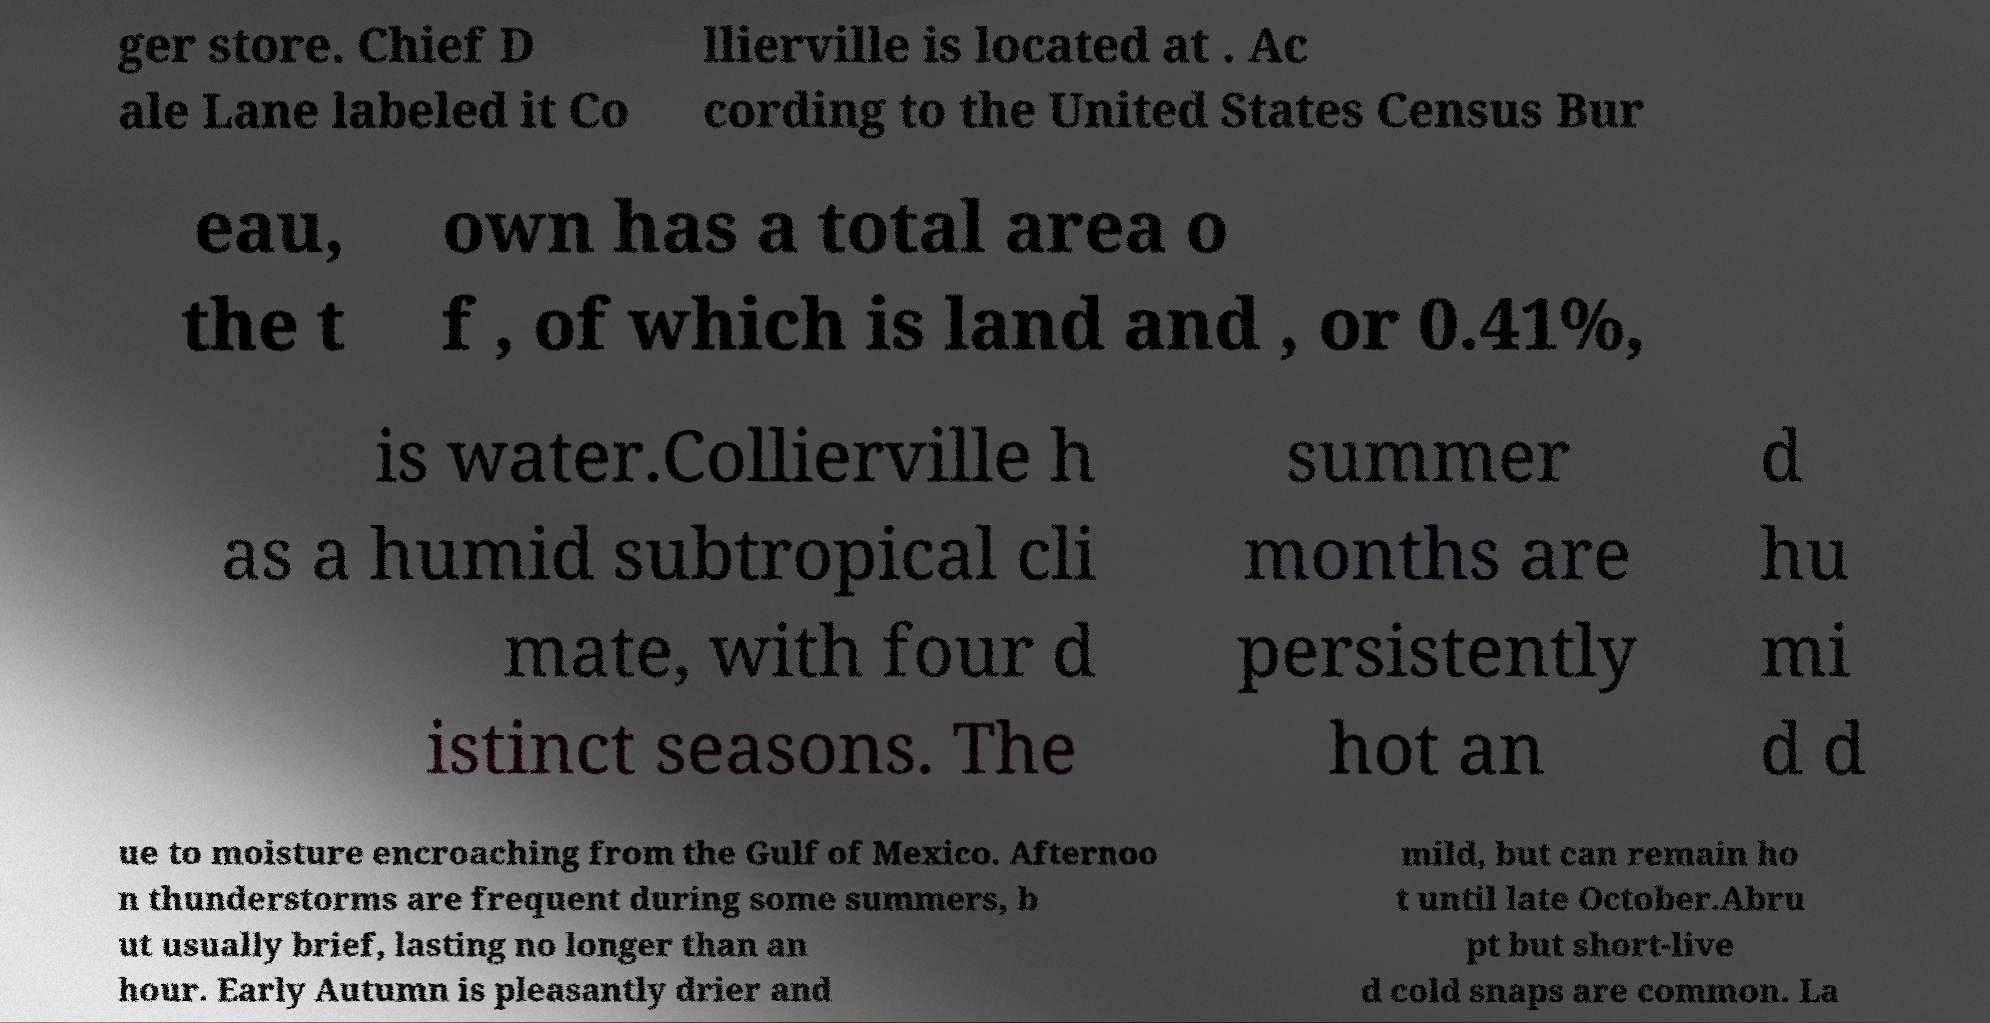Can you read and provide the text displayed in the image?This photo seems to have some interesting text. Can you extract and type it out for me? ger store. Chief D ale Lane labeled it Co llierville is located at . Ac cording to the United States Census Bur eau, the t own has a total area o f , of which is land and , or 0.41%, is water.Collierville h as a humid subtropical cli mate, with four d istinct seasons. The summer months are persistently hot an d hu mi d d ue to moisture encroaching from the Gulf of Mexico. Afternoo n thunderstorms are frequent during some summers, b ut usually brief, lasting no longer than an hour. Early Autumn is pleasantly drier and mild, but can remain ho t until late October.Abru pt but short-live d cold snaps are common. La 